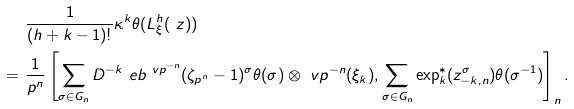Convert formula to latex. <formula><loc_0><loc_0><loc_500><loc_500>& \frac { 1 } { ( h + k - 1 ) ! } \kappa ^ { k } \theta ( \L L _ { \xi } ^ { h } ( \ z ) ) \\ = \ & \frac { 1 } { p ^ { n } } \left [ \sum _ { \sigma \in G _ { n } } D ^ { - k } \ e b ^ { \ v p ^ { - n } } ( \zeta _ { p ^ { n } } - 1 ) ^ { \sigma } \theta ( \sigma ) \otimes \ v p ^ { - n } ( \xi _ { k } ) , \sum _ { \sigma \in G _ { n } } \exp ^ { * } _ { k } ( z _ { - k , n } ^ { \sigma } ) \theta ( \sigma ^ { - 1 } ) \right ] _ { n } .</formula> 